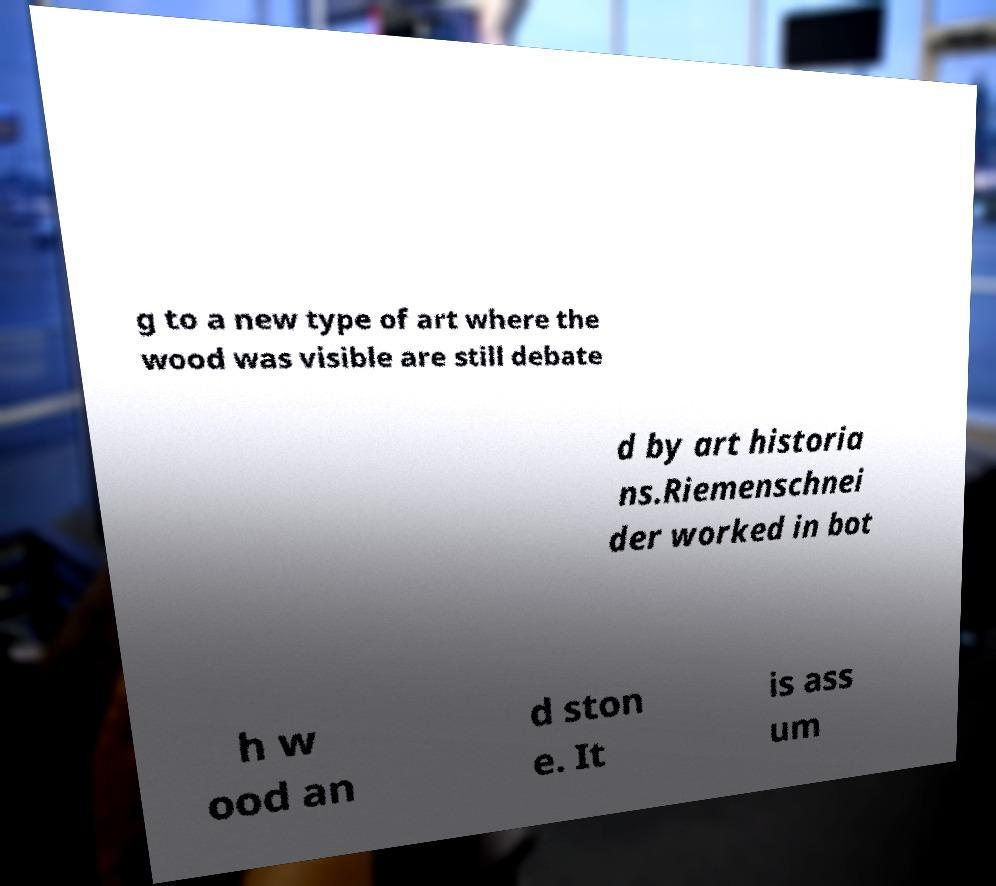There's text embedded in this image that I need extracted. Can you transcribe it verbatim? g to a new type of art where the wood was visible are still debate d by art historia ns.Riemenschnei der worked in bot h w ood an d ston e. It is ass um 